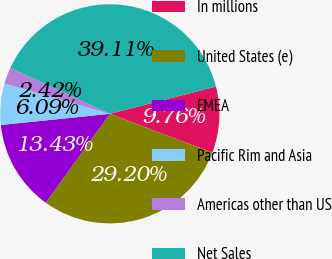Convert chart to OTSL. <chart><loc_0><loc_0><loc_500><loc_500><pie_chart><fcel>In millions<fcel>United States (e)<fcel>EMEA<fcel>Pacific Rim and Asia<fcel>Americas other than US<fcel>Net Sales<nl><fcel>9.76%<fcel>29.2%<fcel>13.43%<fcel>6.09%<fcel>2.42%<fcel>39.11%<nl></chart> 